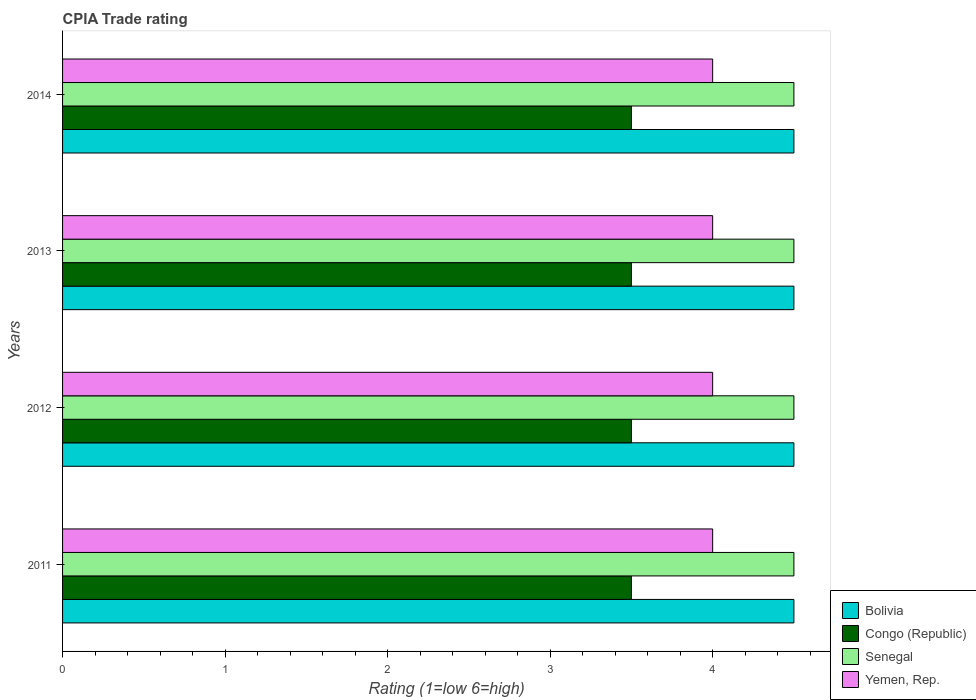How many different coloured bars are there?
Give a very brief answer. 4. How many groups of bars are there?
Your answer should be very brief. 4. How many bars are there on the 3rd tick from the top?
Provide a succinct answer. 4. How many bars are there on the 3rd tick from the bottom?
Ensure brevity in your answer.  4. What is the label of the 4th group of bars from the top?
Give a very brief answer. 2011. In how many cases, is the number of bars for a given year not equal to the number of legend labels?
Give a very brief answer. 0. What is the CPIA rating in Bolivia in 2014?
Provide a short and direct response. 4.5. What is the difference between the CPIA rating in Senegal in 2011 and that in 2013?
Make the answer very short. 0. What is the difference between the CPIA rating in Congo (Republic) in 2011 and the CPIA rating in Bolivia in 2012?
Your response must be concise. -1. What is the average CPIA rating in Bolivia per year?
Your answer should be compact. 4.5. What is the difference between the highest and the second highest CPIA rating in Senegal?
Your answer should be compact. 0. What is the difference between the highest and the lowest CPIA rating in Congo (Republic)?
Offer a very short reply. 0. Is the sum of the CPIA rating in Bolivia in 2012 and 2013 greater than the maximum CPIA rating in Senegal across all years?
Make the answer very short. Yes. What does the 2nd bar from the top in 2012 represents?
Your answer should be compact. Senegal. What does the 3rd bar from the bottom in 2013 represents?
Offer a very short reply. Senegal. Is it the case that in every year, the sum of the CPIA rating in Bolivia and CPIA rating in Senegal is greater than the CPIA rating in Congo (Republic)?
Keep it short and to the point. Yes. What is the difference between two consecutive major ticks on the X-axis?
Provide a short and direct response. 1. Does the graph contain any zero values?
Your response must be concise. No. Where does the legend appear in the graph?
Make the answer very short. Bottom right. What is the title of the graph?
Your response must be concise. CPIA Trade rating. Does "Bulgaria" appear as one of the legend labels in the graph?
Give a very brief answer. No. What is the label or title of the Y-axis?
Keep it short and to the point. Years. What is the Rating (1=low 6=high) in Bolivia in 2011?
Provide a short and direct response. 4.5. What is the Rating (1=low 6=high) of Bolivia in 2012?
Your answer should be compact. 4.5. What is the Rating (1=low 6=high) in Senegal in 2012?
Ensure brevity in your answer.  4.5. What is the Rating (1=low 6=high) in Yemen, Rep. in 2013?
Make the answer very short. 4. What is the Rating (1=low 6=high) in Bolivia in 2014?
Keep it short and to the point. 4.5. What is the Rating (1=low 6=high) of Yemen, Rep. in 2014?
Ensure brevity in your answer.  4. Across all years, what is the maximum Rating (1=low 6=high) in Bolivia?
Give a very brief answer. 4.5. Across all years, what is the maximum Rating (1=low 6=high) of Congo (Republic)?
Your response must be concise. 3.5. Across all years, what is the minimum Rating (1=low 6=high) of Bolivia?
Ensure brevity in your answer.  4.5. Across all years, what is the minimum Rating (1=low 6=high) of Congo (Republic)?
Make the answer very short. 3.5. Across all years, what is the minimum Rating (1=low 6=high) in Yemen, Rep.?
Keep it short and to the point. 4. What is the total Rating (1=low 6=high) of Bolivia in the graph?
Make the answer very short. 18. What is the total Rating (1=low 6=high) in Senegal in the graph?
Provide a succinct answer. 18. What is the total Rating (1=low 6=high) of Yemen, Rep. in the graph?
Make the answer very short. 16. What is the difference between the Rating (1=low 6=high) of Bolivia in 2011 and that in 2012?
Offer a terse response. 0. What is the difference between the Rating (1=low 6=high) in Congo (Republic) in 2011 and that in 2012?
Your answer should be very brief. 0. What is the difference between the Rating (1=low 6=high) of Yemen, Rep. in 2011 and that in 2012?
Ensure brevity in your answer.  0. What is the difference between the Rating (1=low 6=high) in Congo (Republic) in 2011 and that in 2013?
Make the answer very short. 0. What is the difference between the Rating (1=low 6=high) of Yemen, Rep. in 2011 and that in 2013?
Give a very brief answer. 0. What is the difference between the Rating (1=low 6=high) in Bolivia in 2011 and that in 2014?
Make the answer very short. 0. What is the difference between the Rating (1=low 6=high) of Congo (Republic) in 2011 and that in 2014?
Ensure brevity in your answer.  0. What is the difference between the Rating (1=low 6=high) of Senegal in 2011 and that in 2014?
Your answer should be compact. 0. What is the difference between the Rating (1=low 6=high) in Yemen, Rep. in 2011 and that in 2014?
Give a very brief answer. 0. What is the difference between the Rating (1=low 6=high) in Bolivia in 2012 and that in 2013?
Make the answer very short. 0. What is the difference between the Rating (1=low 6=high) in Senegal in 2012 and that in 2013?
Give a very brief answer. 0. What is the difference between the Rating (1=low 6=high) of Yemen, Rep. in 2012 and that in 2013?
Provide a short and direct response. 0. What is the difference between the Rating (1=low 6=high) in Bolivia in 2012 and that in 2014?
Provide a short and direct response. 0. What is the difference between the Rating (1=low 6=high) of Congo (Republic) in 2012 and that in 2014?
Your answer should be very brief. 0. What is the difference between the Rating (1=low 6=high) in Senegal in 2012 and that in 2014?
Make the answer very short. 0. What is the difference between the Rating (1=low 6=high) of Bolivia in 2013 and that in 2014?
Provide a succinct answer. 0. What is the difference between the Rating (1=low 6=high) in Senegal in 2013 and that in 2014?
Provide a short and direct response. 0. What is the difference between the Rating (1=low 6=high) of Yemen, Rep. in 2013 and that in 2014?
Offer a very short reply. 0. What is the difference between the Rating (1=low 6=high) in Bolivia in 2011 and the Rating (1=low 6=high) in Congo (Republic) in 2012?
Your answer should be compact. 1. What is the difference between the Rating (1=low 6=high) of Congo (Republic) in 2011 and the Rating (1=low 6=high) of Yemen, Rep. in 2012?
Provide a short and direct response. -0.5. What is the difference between the Rating (1=low 6=high) of Senegal in 2011 and the Rating (1=low 6=high) of Yemen, Rep. in 2012?
Your answer should be compact. 0.5. What is the difference between the Rating (1=low 6=high) of Bolivia in 2011 and the Rating (1=low 6=high) of Yemen, Rep. in 2013?
Offer a very short reply. 0.5. What is the difference between the Rating (1=low 6=high) in Congo (Republic) in 2011 and the Rating (1=low 6=high) in Senegal in 2013?
Your answer should be compact. -1. What is the difference between the Rating (1=low 6=high) in Congo (Republic) in 2011 and the Rating (1=low 6=high) in Yemen, Rep. in 2013?
Your answer should be compact. -0.5. What is the difference between the Rating (1=low 6=high) in Bolivia in 2011 and the Rating (1=low 6=high) in Congo (Republic) in 2014?
Ensure brevity in your answer.  1. What is the difference between the Rating (1=low 6=high) in Bolivia in 2011 and the Rating (1=low 6=high) in Senegal in 2014?
Keep it short and to the point. 0. What is the difference between the Rating (1=low 6=high) of Congo (Republic) in 2011 and the Rating (1=low 6=high) of Senegal in 2014?
Provide a short and direct response. -1. What is the difference between the Rating (1=low 6=high) of Congo (Republic) in 2011 and the Rating (1=low 6=high) of Yemen, Rep. in 2014?
Ensure brevity in your answer.  -0.5. What is the difference between the Rating (1=low 6=high) in Bolivia in 2012 and the Rating (1=low 6=high) in Congo (Republic) in 2013?
Offer a terse response. 1. What is the difference between the Rating (1=low 6=high) of Bolivia in 2012 and the Rating (1=low 6=high) of Senegal in 2013?
Provide a short and direct response. 0. What is the difference between the Rating (1=low 6=high) in Bolivia in 2012 and the Rating (1=low 6=high) in Yemen, Rep. in 2013?
Offer a terse response. 0.5. What is the difference between the Rating (1=low 6=high) in Senegal in 2012 and the Rating (1=low 6=high) in Yemen, Rep. in 2013?
Your answer should be compact. 0.5. What is the difference between the Rating (1=low 6=high) in Bolivia in 2012 and the Rating (1=low 6=high) in Congo (Republic) in 2014?
Provide a succinct answer. 1. What is the difference between the Rating (1=low 6=high) of Bolivia in 2012 and the Rating (1=low 6=high) of Senegal in 2014?
Offer a very short reply. 0. What is the difference between the Rating (1=low 6=high) of Bolivia in 2012 and the Rating (1=low 6=high) of Yemen, Rep. in 2014?
Provide a short and direct response. 0.5. What is the difference between the Rating (1=low 6=high) of Senegal in 2012 and the Rating (1=low 6=high) of Yemen, Rep. in 2014?
Your answer should be compact. 0.5. What is the difference between the Rating (1=low 6=high) in Bolivia in 2013 and the Rating (1=low 6=high) in Yemen, Rep. in 2014?
Offer a very short reply. 0.5. What is the difference between the Rating (1=low 6=high) of Congo (Republic) in 2013 and the Rating (1=low 6=high) of Senegal in 2014?
Offer a very short reply. -1. What is the difference between the Rating (1=low 6=high) in Senegal in 2013 and the Rating (1=low 6=high) in Yemen, Rep. in 2014?
Offer a terse response. 0.5. What is the average Rating (1=low 6=high) in Bolivia per year?
Ensure brevity in your answer.  4.5. In the year 2011, what is the difference between the Rating (1=low 6=high) of Bolivia and Rating (1=low 6=high) of Congo (Republic)?
Keep it short and to the point. 1. In the year 2011, what is the difference between the Rating (1=low 6=high) of Bolivia and Rating (1=low 6=high) of Senegal?
Make the answer very short. 0. In the year 2011, what is the difference between the Rating (1=low 6=high) in Bolivia and Rating (1=low 6=high) in Yemen, Rep.?
Your answer should be very brief. 0.5. In the year 2011, what is the difference between the Rating (1=low 6=high) in Congo (Republic) and Rating (1=low 6=high) in Yemen, Rep.?
Ensure brevity in your answer.  -0.5. In the year 2011, what is the difference between the Rating (1=low 6=high) in Senegal and Rating (1=low 6=high) in Yemen, Rep.?
Offer a terse response. 0.5. In the year 2012, what is the difference between the Rating (1=low 6=high) in Bolivia and Rating (1=low 6=high) in Yemen, Rep.?
Provide a succinct answer. 0.5. In the year 2012, what is the difference between the Rating (1=low 6=high) of Congo (Republic) and Rating (1=low 6=high) of Senegal?
Offer a terse response. -1. In the year 2012, what is the difference between the Rating (1=low 6=high) of Senegal and Rating (1=low 6=high) of Yemen, Rep.?
Offer a terse response. 0.5. In the year 2013, what is the difference between the Rating (1=low 6=high) in Bolivia and Rating (1=low 6=high) in Senegal?
Make the answer very short. 0. In the year 2014, what is the difference between the Rating (1=low 6=high) in Bolivia and Rating (1=low 6=high) in Yemen, Rep.?
Your answer should be very brief. 0.5. In the year 2014, what is the difference between the Rating (1=low 6=high) in Congo (Republic) and Rating (1=low 6=high) in Yemen, Rep.?
Your answer should be very brief. -0.5. In the year 2014, what is the difference between the Rating (1=low 6=high) in Senegal and Rating (1=low 6=high) in Yemen, Rep.?
Your answer should be compact. 0.5. What is the ratio of the Rating (1=low 6=high) of Congo (Republic) in 2011 to that in 2012?
Offer a very short reply. 1. What is the ratio of the Rating (1=low 6=high) in Senegal in 2011 to that in 2012?
Make the answer very short. 1. What is the ratio of the Rating (1=low 6=high) of Bolivia in 2011 to that in 2013?
Your answer should be very brief. 1. What is the ratio of the Rating (1=low 6=high) in Congo (Republic) in 2011 to that in 2013?
Your response must be concise. 1. What is the ratio of the Rating (1=low 6=high) in Bolivia in 2011 to that in 2014?
Your answer should be very brief. 1. What is the ratio of the Rating (1=low 6=high) of Bolivia in 2012 to that in 2013?
Provide a short and direct response. 1. What is the ratio of the Rating (1=low 6=high) in Congo (Republic) in 2012 to that in 2014?
Provide a short and direct response. 1. What is the ratio of the Rating (1=low 6=high) in Yemen, Rep. in 2012 to that in 2014?
Provide a succinct answer. 1. What is the ratio of the Rating (1=low 6=high) in Bolivia in 2013 to that in 2014?
Provide a succinct answer. 1. What is the ratio of the Rating (1=low 6=high) in Senegal in 2013 to that in 2014?
Offer a terse response. 1. What is the ratio of the Rating (1=low 6=high) in Yemen, Rep. in 2013 to that in 2014?
Make the answer very short. 1. What is the difference between the highest and the second highest Rating (1=low 6=high) of Congo (Republic)?
Your response must be concise. 0. What is the difference between the highest and the lowest Rating (1=low 6=high) in Bolivia?
Give a very brief answer. 0. What is the difference between the highest and the lowest Rating (1=low 6=high) in Senegal?
Your response must be concise. 0. What is the difference between the highest and the lowest Rating (1=low 6=high) of Yemen, Rep.?
Your answer should be compact. 0. 